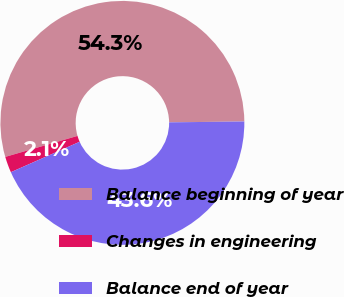<chart> <loc_0><loc_0><loc_500><loc_500><pie_chart><fcel>Balance beginning of year<fcel>Changes in engineering<fcel>Balance end of year<nl><fcel>54.31%<fcel>2.13%<fcel>43.55%<nl></chart> 